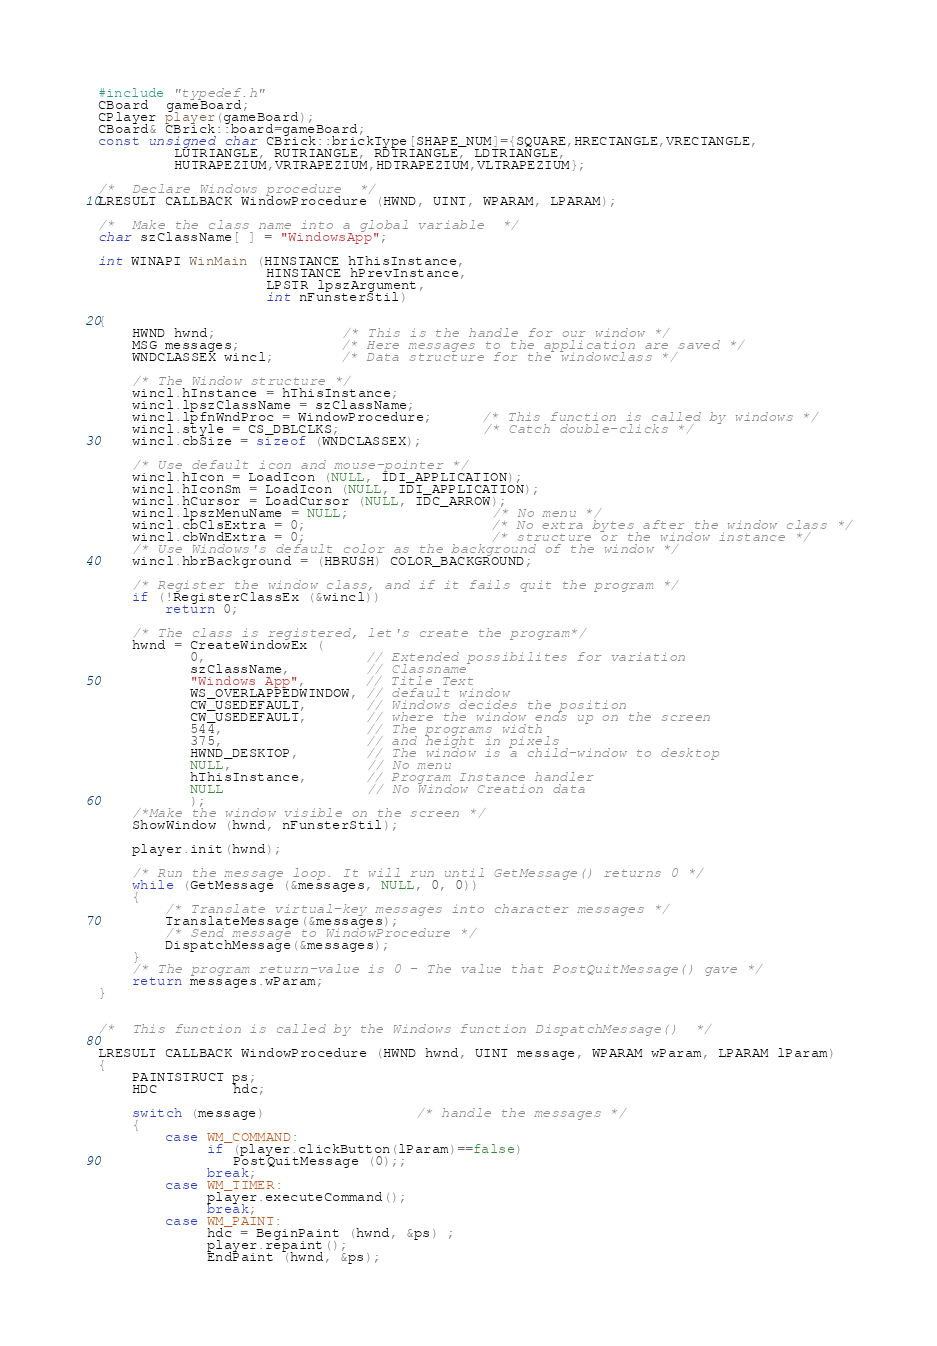<code> <loc_0><loc_0><loc_500><loc_500><_C++_>#include "typedef.h"
CBoard  gameBoard;
CPlayer player(gameBoard);
CBoard& CBrick::board=gameBoard;
const unsigned char CBrick::brickType[SHAPE_NUM]={SQUARE,HRECTANGLE,VRECTANGLE,
         LUTRIANGLE, RUTRIANGLE, RDTRIANGLE, LDTRIANGLE,
         HUTRAPEZIUM,VRTRAPEZIUM,HDTRAPEZIUM,VLTRAPEZIUM};

/*  Declare Windows procedure  */
LRESULT CALLBACK WindowProcedure (HWND, UINT, WPARAM, LPARAM);

/*  Make the class name into a global variable  */
char szClassName[ ] = "WindowsApp";

int WINAPI WinMain (HINSTANCE hThisInstance,
                    HINSTANCE hPrevInstance,
                    LPSTR lpszArgument,
                    int nFunsterStil)

{
    HWND hwnd;               /* This is the handle for our window */
    MSG messages;            /* Here messages to the application are saved */
    WNDCLASSEX wincl;        /* Data structure for the windowclass */

    /* The Window structure */
    wincl.hInstance = hThisInstance;
    wincl.lpszClassName = szClassName;
    wincl.lpfnWndProc = WindowProcedure;      /* This function is called by windows */
    wincl.style = CS_DBLCLKS;                 /* Catch double-clicks */
    wincl.cbSize = sizeof (WNDCLASSEX);

    /* Use default icon and mouse-pointer */
    wincl.hIcon = LoadIcon (NULL, IDI_APPLICATION);
    wincl.hIconSm = LoadIcon (NULL, IDI_APPLICATION);
    wincl.hCursor = LoadCursor (NULL, IDC_ARROW);
    wincl.lpszMenuName = NULL;                 /* No menu */
    wincl.cbClsExtra = 0;                      /* No extra bytes after the window class */
    wincl.cbWndExtra = 0;                      /* structure or the window instance */
    /* Use Windows's default color as the background of the window */
    wincl.hbrBackground = (HBRUSH) COLOR_BACKGROUND;

    /* Register the window class, and if it fails quit the program */
    if (!RegisterClassEx (&wincl))
        return 0;

    /* The class is registered, let's create the program*/
    hwnd = CreateWindowEx (
           0,                   // Extended possibilites for variation 
           szClassName,         // Classname 
           "Windows App",       // Title Text 
           WS_OVERLAPPEDWINDOW, // default window 
           CW_USEDEFAULT,       // Windows decides the position 
           CW_USEDEFAULT,       // where the window ends up on the screen 
           544,                 // The programs width 
           375,                 // and height in pixels 
           HWND_DESKTOP,        // The window is a child-window to desktop 
           NULL,                // No menu 
           hThisInstance,       // Program Instance handler 
           NULL                 // No Window Creation data 
           );
    /*Make the window visible on the screen */
    ShowWindow (hwnd, nFunsterStil);
    
    player.init(hwnd);
    
    /* Run the message loop. It will run until GetMessage() returns 0 */
    while (GetMessage (&messages, NULL, 0, 0))
    {
        /* Translate virtual-key messages into character messages */
        TranslateMessage(&messages);
        /* Send message to WindowProcedure */
        DispatchMessage(&messages);
    }
    /* The program return-value is 0 - The value that PostQuitMessage() gave */
    return messages.wParam;
}


/*  This function is called by the Windows function DispatchMessage()  */

LRESULT CALLBACK WindowProcedure (HWND hwnd, UINT message, WPARAM wParam, LPARAM lParam)
{
	PAINTSTRUCT ps;
	HDC         hdc;

    switch (message)                  /* handle the messages */
    {
        case WM_COMMAND:
             if (player.clickButton(lParam)==false)
                PostQuitMessage (0);;
             break;
        case WM_TIMER:
             player.executeCommand();
             break;
	    case WM_PAINT:
             hdc = BeginPaint (hwnd, &ps) ;
             player.repaint();
             EndPaint (hwnd, &ps);</code> 